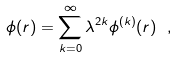<formula> <loc_0><loc_0><loc_500><loc_500>\phi ( r ) = \sum _ { k = 0 } ^ { \infty } \lambda ^ { 2 k } \phi ^ { ( k ) } ( r ) \ ,</formula> 